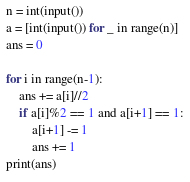Convert code to text. <code><loc_0><loc_0><loc_500><loc_500><_Python_>n = int(input())
a = [int(input()) for _ in range(n)]
ans = 0

for i in range(n-1):
    ans += a[i]//2
    if a[i]%2 == 1 and a[i+1] == 1:
        a[i+1] -= 1
        ans += 1
print(ans)
</code> 